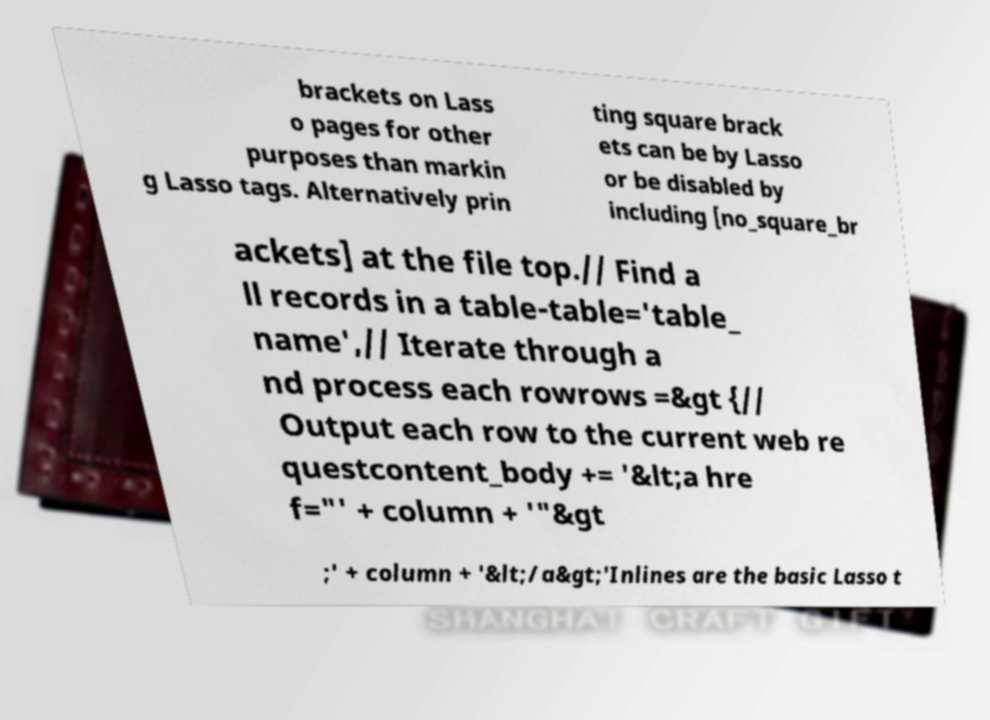Please identify and transcribe the text found in this image. brackets on Lass o pages for other purposes than markin g Lasso tags. Alternatively prin ting square brack ets can be by Lasso or be disabled by including [no_square_br ackets] at the file top.// Find a ll records in a table-table='table_ name',// Iterate through a nd process each rowrows =&gt {// Output each row to the current web re questcontent_body += '&lt;a hre f="' + column + '"&gt ;' + column + '&lt;/a&gt;'Inlines are the basic Lasso t 